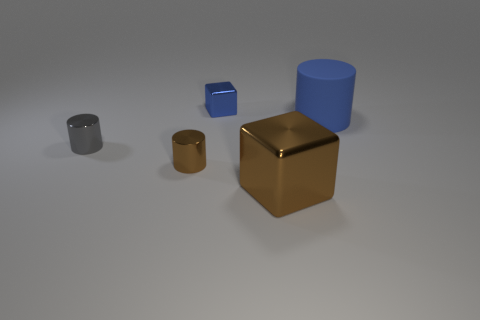How many other objects are there of the same shape as the rubber object?
Your response must be concise. 2. The blue cylinder has what size?
Your answer should be very brief. Large. There is a thing that is both on the right side of the brown metal cylinder and on the left side of the large brown block; what size is it?
Provide a short and direct response. Small. What shape is the small thing behind the blue cylinder?
Keep it short and to the point. Cube. Is the large cylinder made of the same material as the cube that is to the left of the large brown metallic thing?
Provide a short and direct response. No. Is the small brown object the same shape as the large brown thing?
Ensure brevity in your answer.  No. What is the material of the small thing that is the same shape as the big brown metal object?
Keep it short and to the point. Metal. What color is the metal object that is to the right of the small brown metal object and behind the big metal cube?
Give a very brief answer. Blue. The large metallic object is what color?
Provide a short and direct response. Brown. There is a tiny thing that is the same color as the large rubber thing; what is its material?
Offer a very short reply. Metal. 